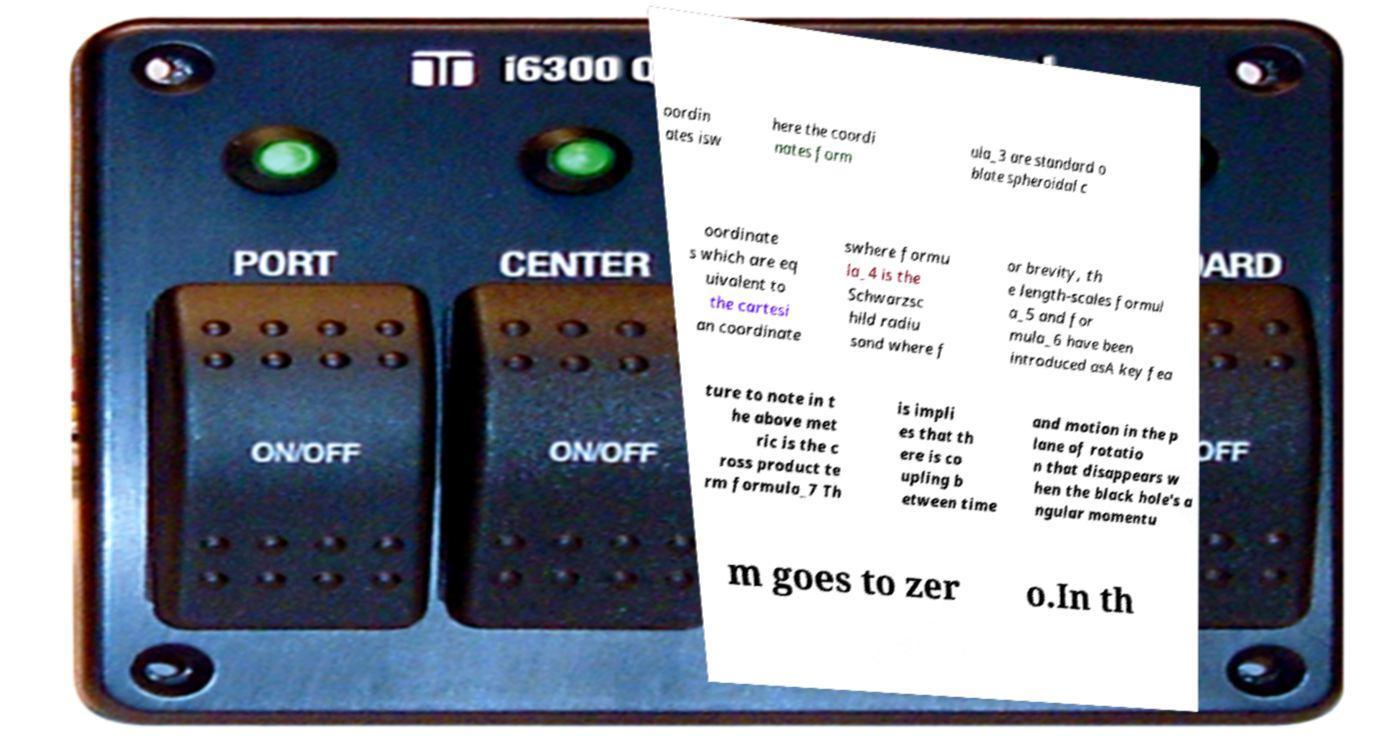There's text embedded in this image that I need extracted. Can you transcribe it verbatim? oordin ates isw here the coordi nates form ula_3 are standard o blate spheroidal c oordinate s which are eq uivalent to the cartesi an coordinate swhere formu la_4 is the Schwarzsc hild radiu sand where f or brevity, th e length-scales formul a_5 and for mula_6 have been introduced asA key fea ture to note in t he above met ric is the c ross product te rm formula_7 Th is impli es that th ere is co upling b etween time and motion in the p lane of rotatio n that disappears w hen the black hole's a ngular momentu m goes to zer o.In th 